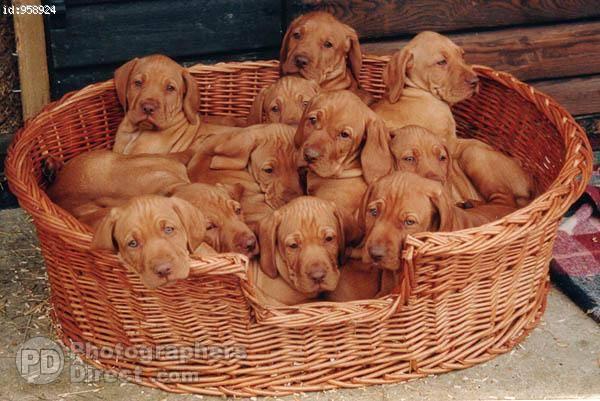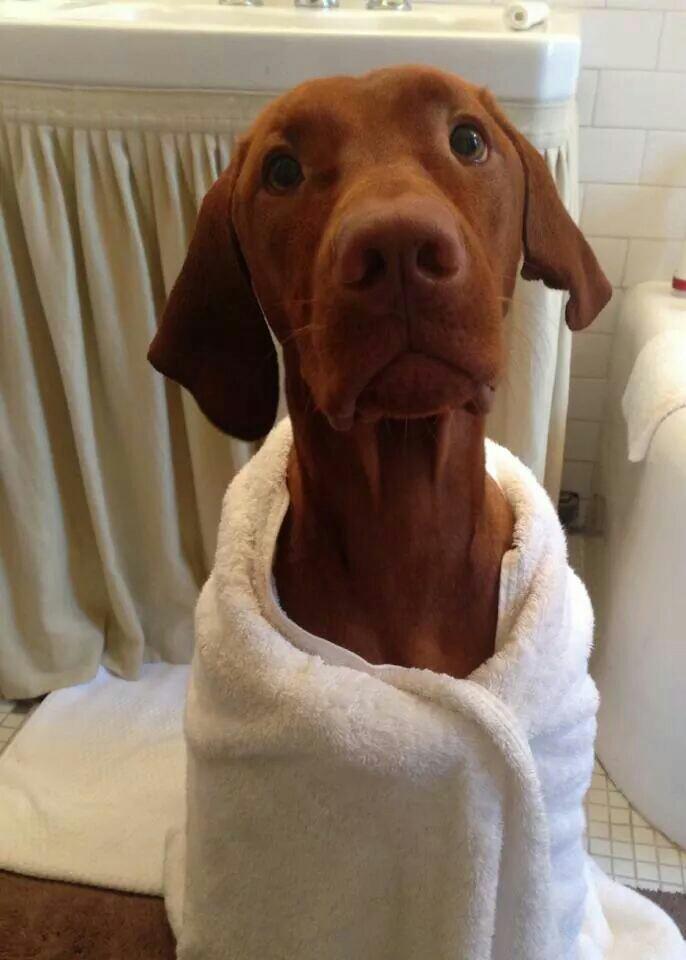The first image is the image on the left, the second image is the image on the right. For the images shown, is this caption "The left image shows one dog gazing with an upright head, and the right image shows a dog reclining with its front paws forward and its head rightside-up." true? Answer yes or no. No. The first image is the image on the left, the second image is the image on the right. Given the left and right images, does the statement "A dog is laying on its stomach in the right image." hold true? Answer yes or no. No. 